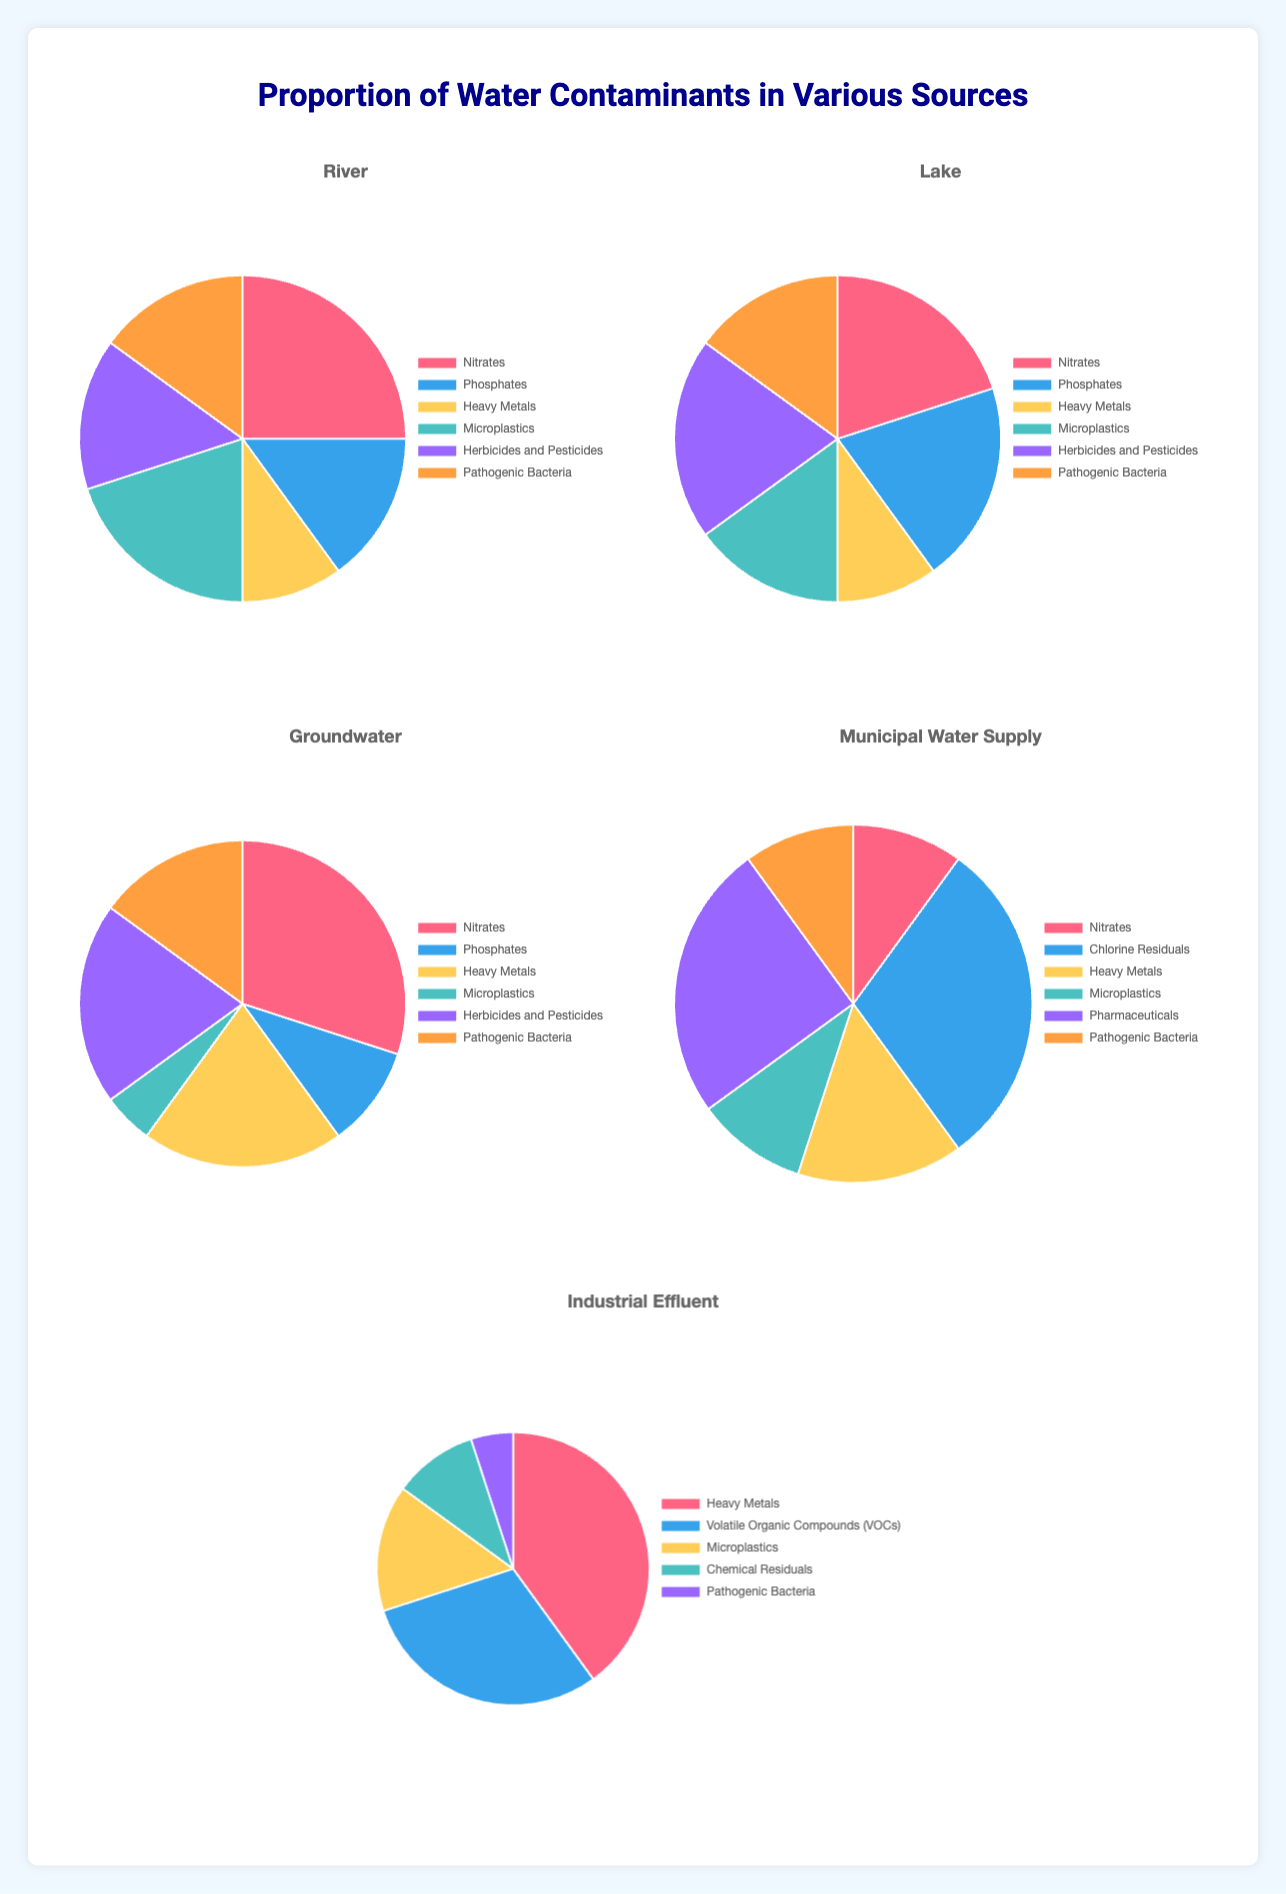Which water source has the highest proportion of Heavy Metals? To determine this, compare the proportions of Heavy Metals in all water sources. River: 10%, Lake: 10%, Groundwater: 20%, Municipal Water Supply: 15%, Industrial Effluent: 40%. Industrial Effluent has the highest proportion.
Answer: Industrial Effluent Which contaminant accounts for the largest proportion in Municipal Water Supply? Look at the pie chart for Municipal Water Supply and identify the contaminant with the largest slice. Chlorine Residuals have the largest slice at 30%.
Answer: Chlorine Residuals What is the combined proportion of Nitrates and Pathogenic Bacteria in the River source? From the River pie chart, Nitrates: 25%, Pathogenic Bacteria: 15%. Sum them up: 25% + 15% = 40%.
Answer: 40% Which water source has the smallest proportion of Microplastics? Compare the proportions of Microplastics across all water sources. River: 20%, Lake: 15%, Groundwater: 5%, Municipal Water Supply: 10%, Industrial Effluent: 15%. Groundwater has the smallest proportion of 5%.
Answer: Groundwater Compare the proportions of Nitrates in River and Municipal Water Supply. Which one is larger? River has 25% Nitrates while Municipal Water Supply has 10%. Therefore, River has a larger proportion.
Answer: River What is the total proportion of Heavy Metals in all water sources combined? Sum the proportions of Heavy Metals from all sources: River: 10%, Lake: 10%, Groundwater: 20%, Municipal Water Supply: 15%, Industrial Effluent: 40%. Total: 10% + 10% + 20% + 15% + 40% = 95%.
Answer: 95% Which contaminant appears in all five water sources? Identify the contaminants present in all sources: River, Lake, Groundwater, Municipal Water Supply, and Industrial Effluent. "Heavy Metals" and "Pathogenic Bacteria" appear in all five.
Answer: Heavy Metals, Pathogenic Bacteria 